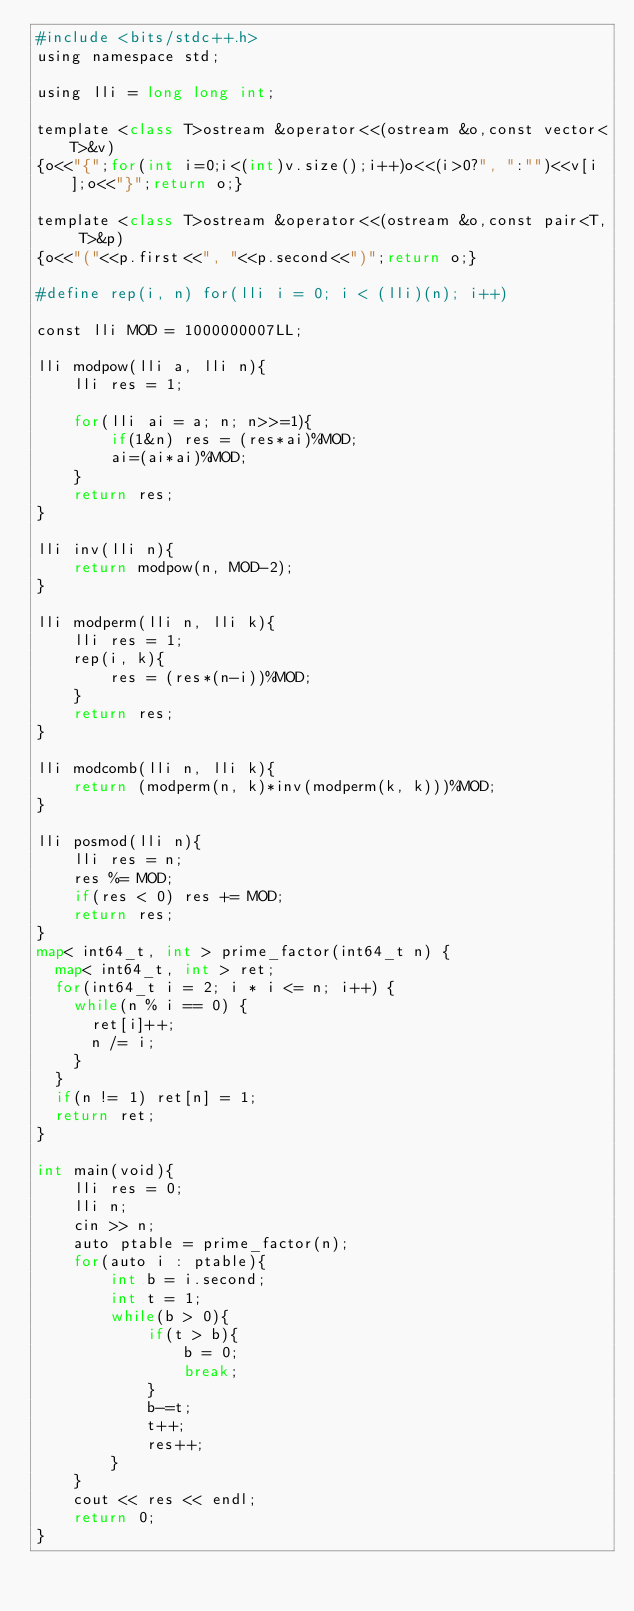<code> <loc_0><loc_0><loc_500><loc_500><_Python_>#include <bits/stdc++.h>
using namespace std;

using lli = long long int;

template <class T>ostream &operator<<(ostream &o,const vector<T>&v)
{o<<"{";for(int i=0;i<(int)v.size();i++)o<<(i>0?", ":"")<<v[i];o<<"}";return o;}

template <class T>ostream &operator<<(ostream &o,const pair<T, T>&p)
{o<<"("<<p.first<<", "<<p.second<<")";return o;}

#define rep(i, n) for(lli i = 0; i < (lli)(n); i++)

const lli MOD = 1000000007LL;

lli modpow(lli a, lli n){
    lli res = 1;

    for(lli ai = a; n; n>>=1){
        if(1&n) res = (res*ai)%MOD;
        ai=(ai*ai)%MOD;
    }
    return res;
}

lli inv(lli n){
    return modpow(n, MOD-2);
}

lli modperm(lli n, lli k){
    lli res = 1;
    rep(i, k){
        res = (res*(n-i))%MOD;
    }
    return res;
}

lli modcomb(lli n, lli k){
    return (modperm(n, k)*inv(modperm(k, k)))%MOD;
}

lli posmod(lli n){
    lli res = n;
    res %= MOD;
    if(res < 0) res += MOD;
    return res;
}
map< int64_t, int > prime_factor(int64_t n) {
  map< int64_t, int > ret;
  for(int64_t i = 2; i * i <= n; i++) {
    while(n % i == 0) {
      ret[i]++;
      n /= i;
    }
  }
  if(n != 1) ret[n] = 1;
  return ret;
}

int main(void){
    lli res = 0;
    lli n;
    cin >> n;
    auto ptable = prime_factor(n);
    for(auto i : ptable){
        int b = i.second;
        int t = 1;
        while(b > 0){
            if(t > b){
                b = 0;
                break;
            }
            b-=t;
            t++;
            res++;
        }
    }
    cout << res << endl;
    return 0;
}
</code> 